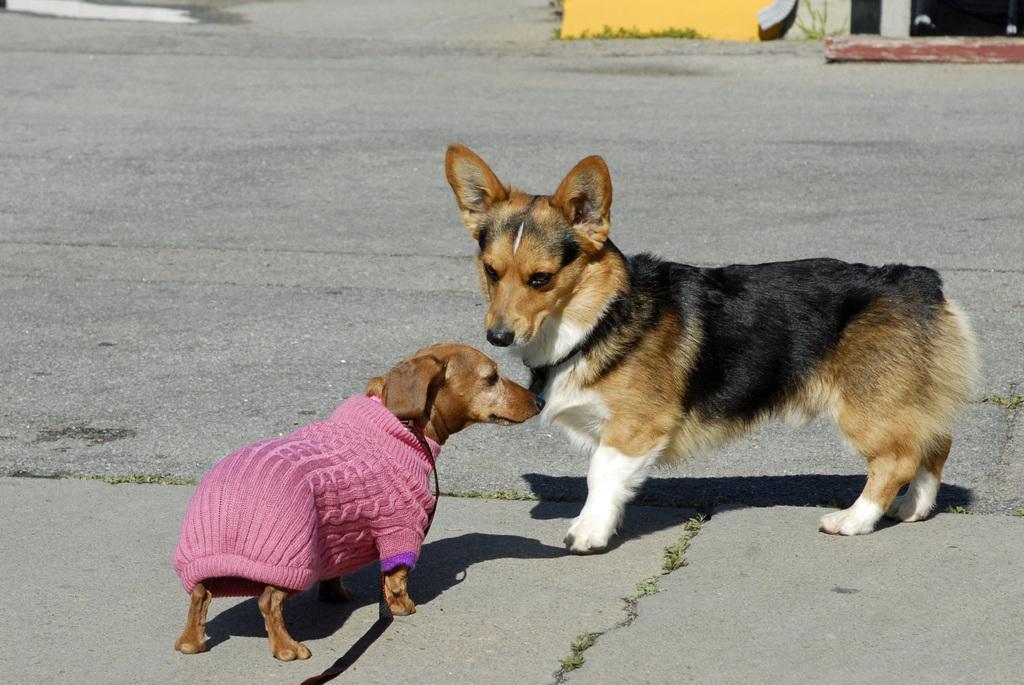Please provide a concise description of this image. In this picture we can see couple of dogs, the left side dog wore a dress. 